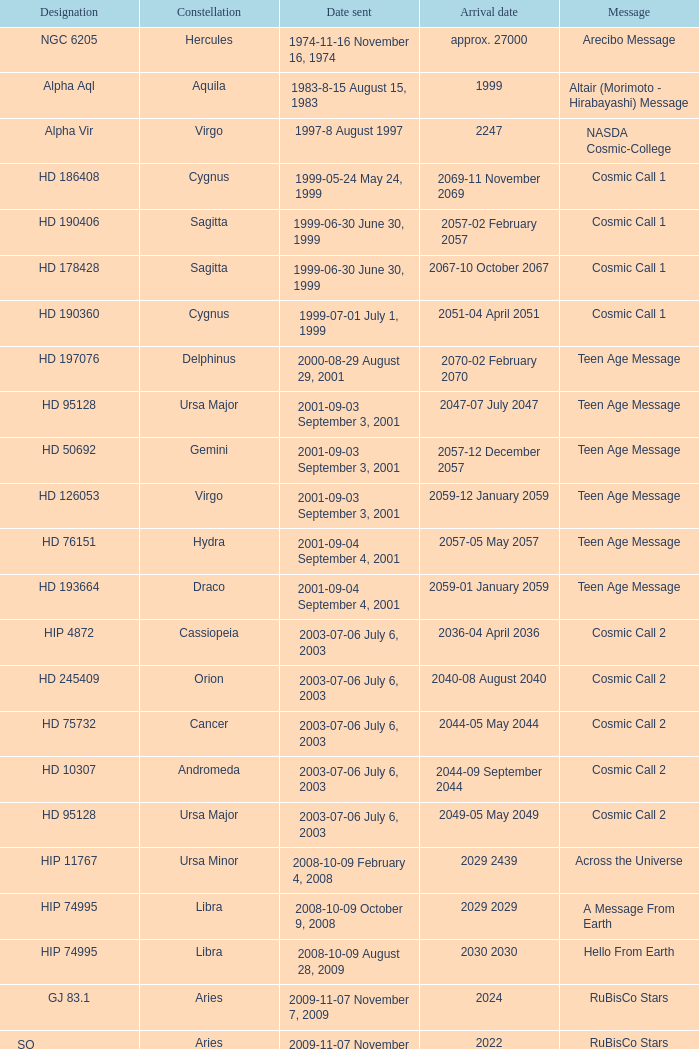What is the location of hip 4872? Cassiopeia. 